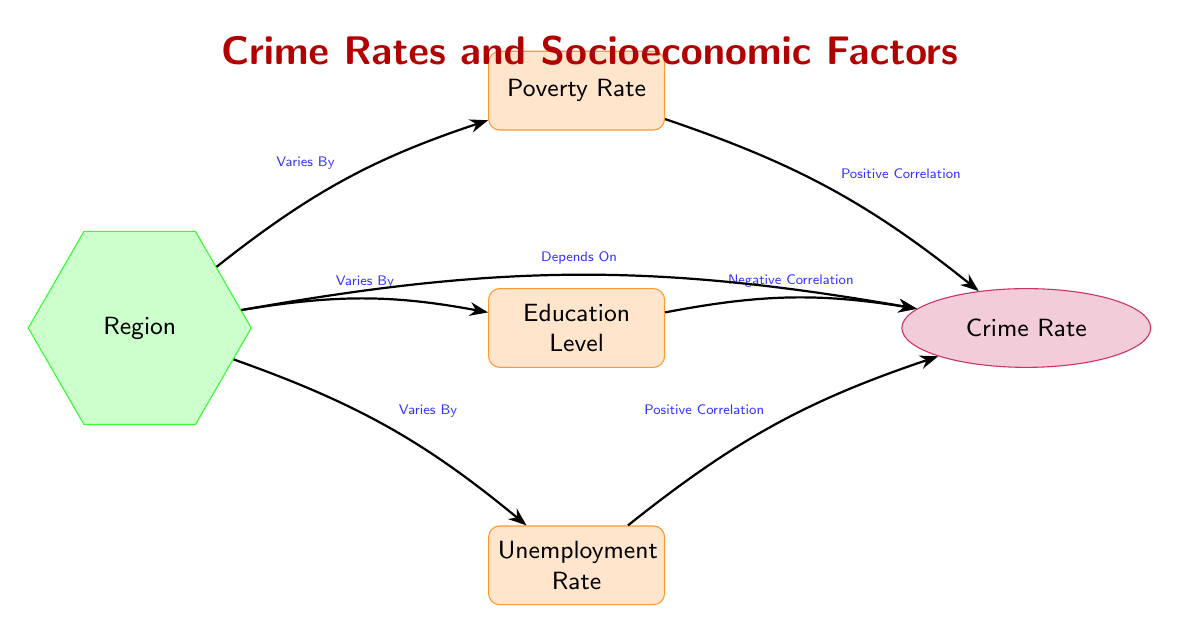What's the relationship between poverty rate and crime rate? The diagram shows a "Positive Correlation" between the poverty rate and the crime rate, indicating that as poverty increases, crime rates tend to increase as well.
Answer: Positive Correlation How many socioeconomic factors are depicted in the diagram? There are three socioeconomic factors mentioned in the diagram: Poverty Rate, Education Level, and Unemployment Rate. Adding these up gives us a total of three.
Answer: 3 What type of correlation exists between education level and crime rate? The diagram illustrates a "Negative Correlation" between education level and crime rate, meaning higher education levels are associated with lower crime rates.
Answer: Negative Correlation What does the region node in the diagram represent? The region node indicates that the socioeconomic factors (poverty, education level, unemployment rate) and crime rates "Varies By" region, highlighting the differing influence of these factors based on geographical locations.
Answer: Varies By How do unemployment rates correlate with crime rates? According to the diagram, there is a "Positive Correlation" between unemployment rates and crime rates, suggesting that as unemployment rates go up, crime rates also tend to increase.
Answer: Positive Correlation Which socio-economic factor has a negative correlation with crime rates? The diagram clearly indicates that the "Education Level" has a negative correlation with crime rates, implying that increased education levels can lead to decreased crime rates.
Answer: Education Level What dependence relationship is indicated in the diagram? The diagram states that crime rates "Depends On" the region, pinpointing that crime rates can be influenced by various conditions based on the geographic area.
Answer: Depends On Which factor has the strongest positive correlation with crime rates? Both the poverty rate and unemployment rate show positive correlations with crime rates, but the diagram does not specify which is stronger. Each would require additional data to determine strength.
Answer: Not specified in diagram How many edges connect the socio-economic factors to the crime rate? The diagram shows a total of three edges connecting the socioeconomic factors (poverty, education, unemployment) to the crime rate.
Answer: 3 